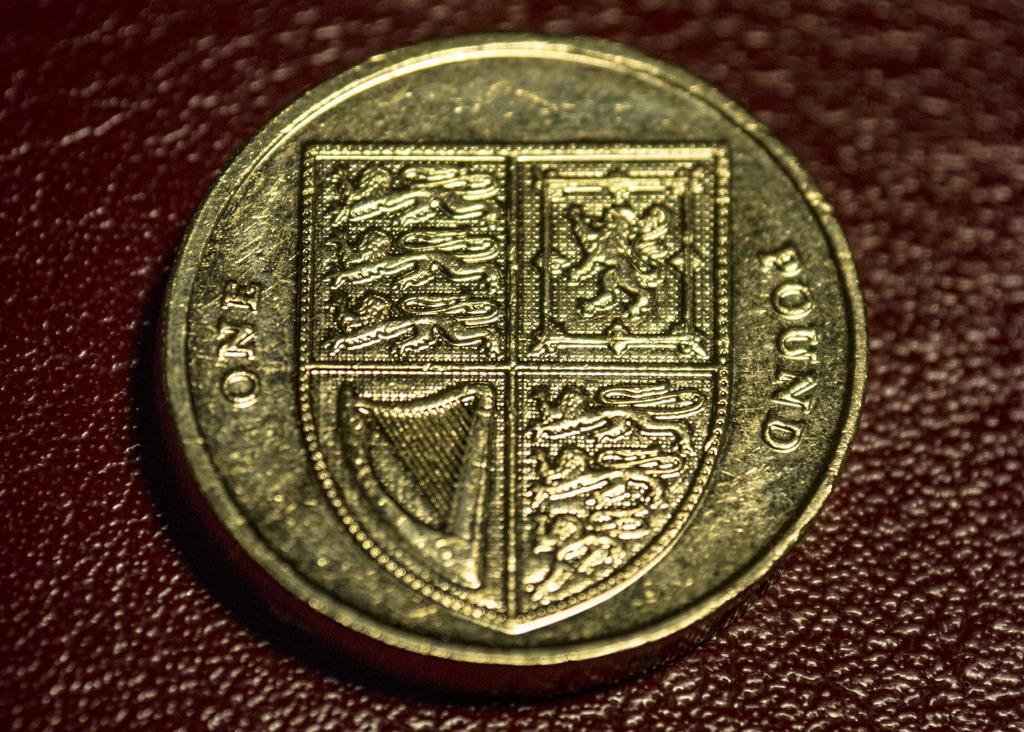What object is in the image? There is a coin in the image. What can be said about the color of the coin? The coin has a cold color. What features are present on the coin? The coin has symbols and text on it. Where is the coin located in the image? The coin is placed on the moon surface. What type of nail is being used by the farmer in the image? There is no farmer or nail present in the image; it features a coin on the moon surface. 